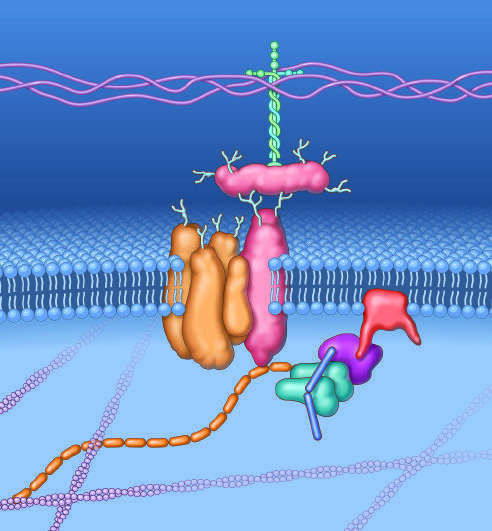what is made by dystrophin?
Answer the question using a single word or phrase. A key set of connections 